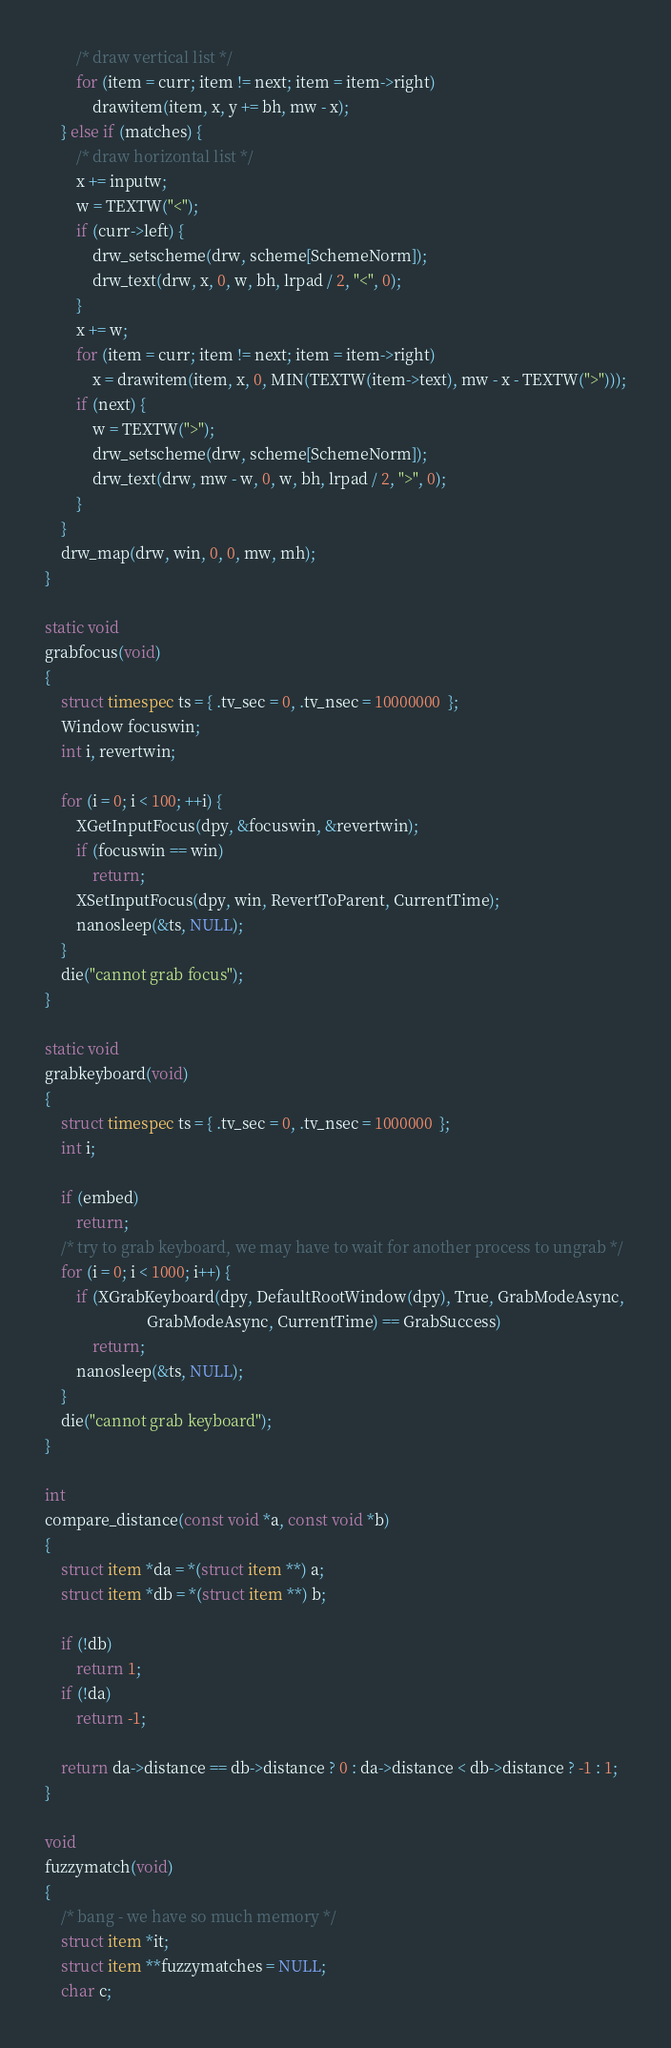Convert code to text. <code><loc_0><loc_0><loc_500><loc_500><_C_>		/* draw vertical list */
		for (item = curr; item != next; item = item->right)
			drawitem(item, x, y += bh, mw - x);
	} else if (matches) {
		/* draw horizontal list */
		x += inputw;
		w = TEXTW("<");
		if (curr->left) {
			drw_setscheme(drw, scheme[SchemeNorm]);
			drw_text(drw, x, 0, w, bh, lrpad / 2, "<", 0);
		}
		x += w;
		for (item = curr; item != next; item = item->right)
			x = drawitem(item, x, 0, MIN(TEXTW(item->text), mw - x - TEXTW(">")));
		if (next) {
			w = TEXTW(">");
			drw_setscheme(drw, scheme[SchemeNorm]);
			drw_text(drw, mw - w, 0, w, bh, lrpad / 2, ">", 0);
		}
	}
	drw_map(drw, win, 0, 0, mw, mh);
}

static void
grabfocus(void)
{
	struct timespec ts = { .tv_sec = 0, .tv_nsec = 10000000  };
	Window focuswin;
	int i, revertwin;

	for (i = 0; i < 100; ++i) {
		XGetInputFocus(dpy, &focuswin, &revertwin);
		if (focuswin == win)
			return;
		XSetInputFocus(dpy, win, RevertToParent, CurrentTime);
		nanosleep(&ts, NULL);
	}
	die("cannot grab focus");
}

static void
grabkeyboard(void)
{
	struct timespec ts = { .tv_sec = 0, .tv_nsec = 1000000  };
	int i;

	if (embed)
		return;
	/* try to grab keyboard, we may have to wait for another process to ungrab */
	for (i = 0; i < 1000; i++) {
		if (XGrabKeyboard(dpy, DefaultRootWindow(dpy), True, GrabModeAsync,
		                  GrabModeAsync, CurrentTime) == GrabSuccess)
			return;
		nanosleep(&ts, NULL);
	}
	die("cannot grab keyboard");
}

int
compare_distance(const void *a, const void *b)
{
	struct item *da = *(struct item **) a;
	struct item *db = *(struct item **) b;

	if (!db)
		return 1;
	if (!da)
		return -1;

	return da->distance == db->distance ? 0 : da->distance < db->distance ? -1 : 1;
}

void
fuzzymatch(void)
{
	/* bang - we have so much memory */
	struct item *it;
	struct item **fuzzymatches = NULL;
	char c;</code> 